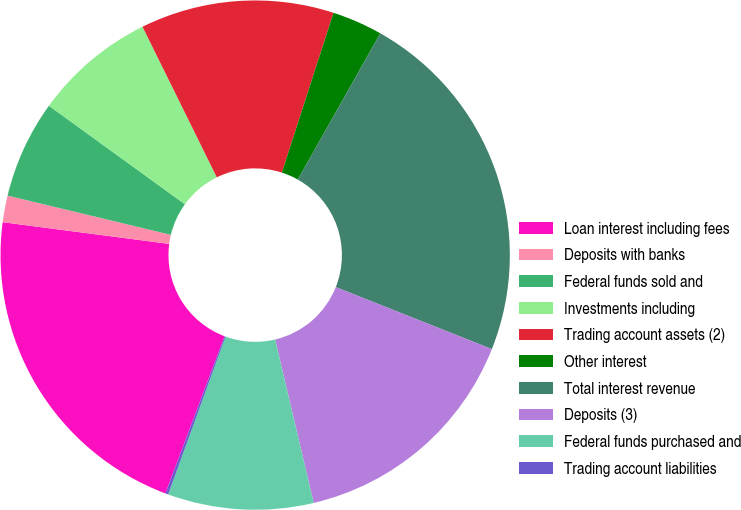<chart> <loc_0><loc_0><loc_500><loc_500><pie_chart><fcel>Loan interest including fees<fcel>Deposits with banks<fcel>Federal funds sold and<fcel>Investments including<fcel>Trading account assets (2)<fcel>Other interest<fcel>Total interest revenue<fcel>Deposits (3)<fcel>Federal funds purchased and<fcel>Trading account liabilities<nl><fcel>21.33%<fcel>1.69%<fcel>6.22%<fcel>7.73%<fcel>12.27%<fcel>3.2%<fcel>22.84%<fcel>15.29%<fcel>9.24%<fcel>0.18%<nl></chart> 